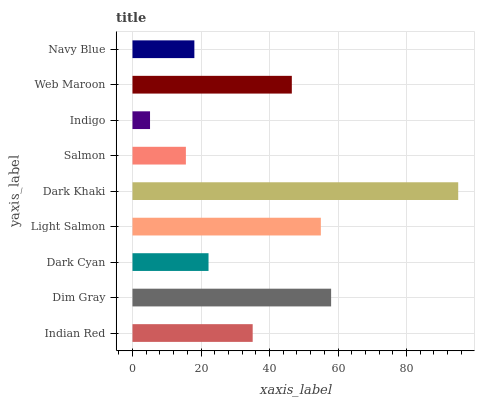Is Indigo the minimum?
Answer yes or no. Yes. Is Dark Khaki the maximum?
Answer yes or no. Yes. Is Dim Gray the minimum?
Answer yes or no. No. Is Dim Gray the maximum?
Answer yes or no. No. Is Dim Gray greater than Indian Red?
Answer yes or no. Yes. Is Indian Red less than Dim Gray?
Answer yes or no. Yes. Is Indian Red greater than Dim Gray?
Answer yes or no. No. Is Dim Gray less than Indian Red?
Answer yes or no. No. Is Indian Red the high median?
Answer yes or no. Yes. Is Indian Red the low median?
Answer yes or no. Yes. Is Dim Gray the high median?
Answer yes or no. No. Is Dark Cyan the low median?
Answer yes or no. No. 